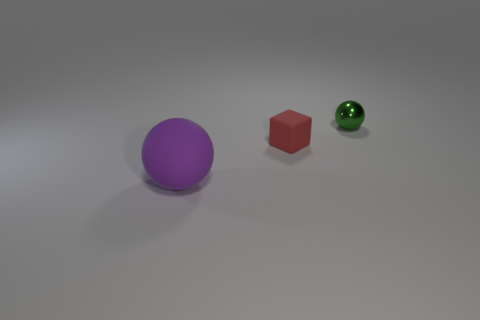There is a block that is the same material as the purple sphere; what size is it?
Your response must be concise. Small. Is there a tiny thing right of the object right of the small object that is to the left of the tiny shiny sphere?
Your response must be concise. No. Do the tiny object that is behind the small rubber thing and the red thing have the same material?
Give a very brief answer. No. What color is the metal object that is the same shape as the large matte object?
Your answer should be very brief. Green. Is there any other thing that has the same shape as the purple rubber thing?
Provide a succinct answer. Yes. Are there an equal number of purple balls that are on the right side of the small red thing and small red things?
Offer a terse response. No. Are there any small green metal objects behind the big purple matte ball?
Keep it short and to the point. Yes. What size is the ball that is left of the small thing that is to the left of the sphere that is behind the large purple rubber sphere?
Provide a succinct answer. Large. Does the thing that is in front of the tiny red matte block have the same shape as the rubber object that is behind the big purple object?
Your answer should be compact. No. The purple rubber object that is the same shape as the small metallic object is what size?
Your response must be concise. Large. 